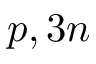<formula> <loc_0><loc_0><loc_500><loc_500>p , 3 n</formula> 